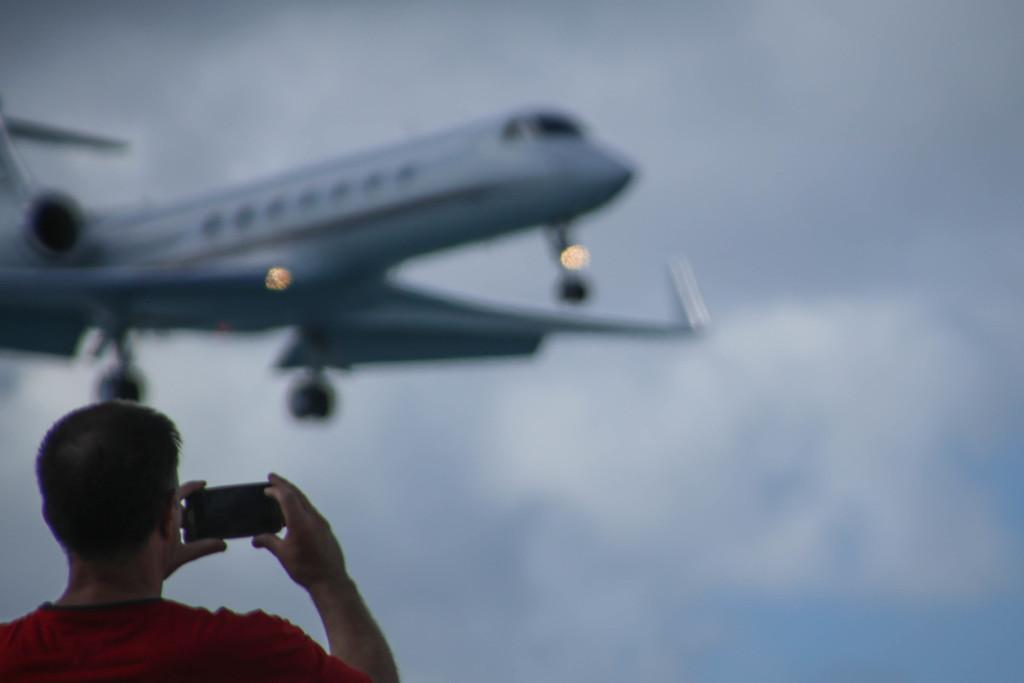Who or what is the main subject in the image? There is a person in the image. What is the person holding in the image? The person is holding a mobile. What can be seen in the background of the image? There is an airplane and the sky. What type of sofa is the person sitting on in the image? There is no sofa present in the image; the person is standing while holding a mobile. What is the person's interest in cooking, as seen in the image? There is no information about the person's interest in cooking in the image. 